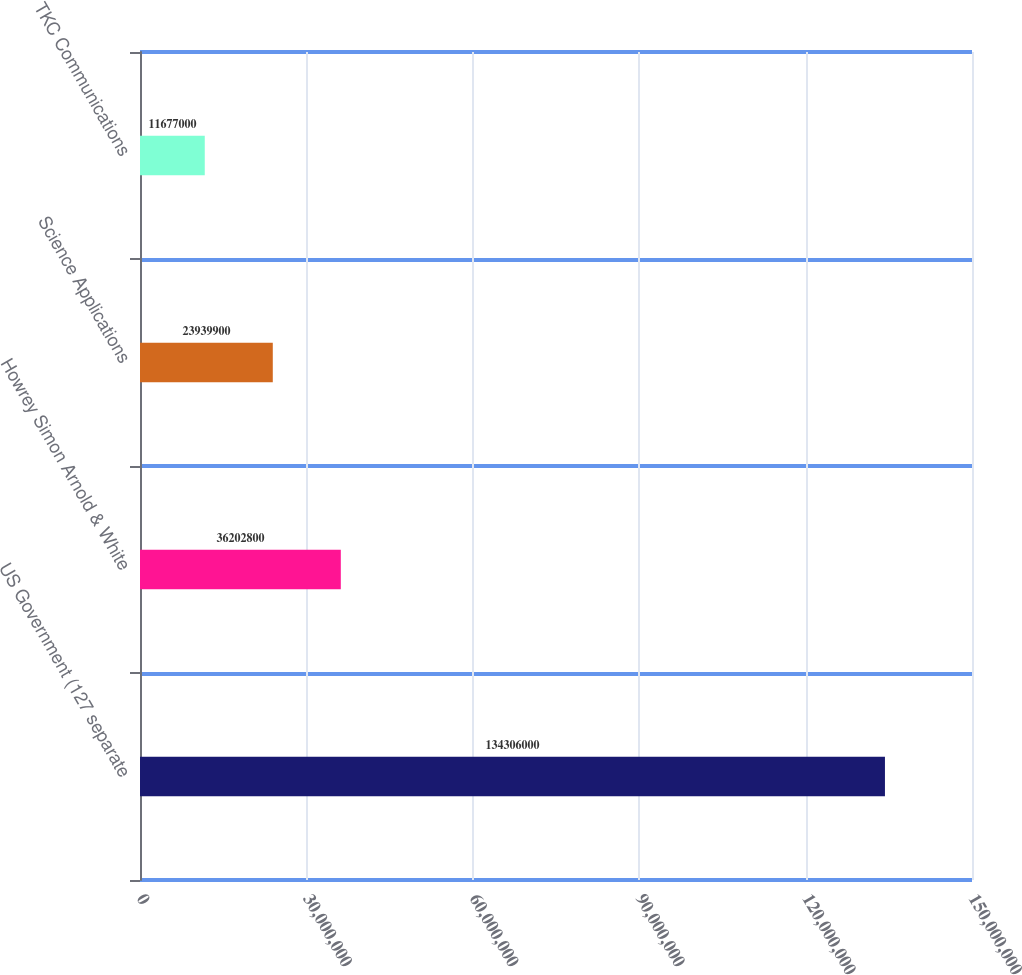<chart> <loc_0><loc_0><loc_500><loc_500><bar_chart><fcel>US Government (127 separate<fcel>Howrey Simon Arnold & White<fcel>Science Applications<fcel>TKC Communications<nl><fcel>1.34306e+08<fcel>3.62028e+07<fcel>2.39399e+07<fcel>1.1677e+07<nl></chart> 